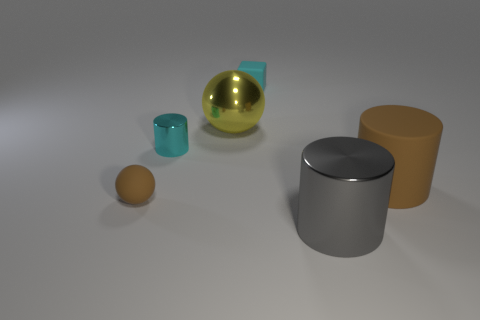Is there anything else that has the same material as the small cylinder?
Ensure brevity in your answer.  Yes. What is the shape of the object that is the same color as the matte block?
Offer a terse response. Cylinder. Are there fewer large brown matte objects that are left of the small cyan block than tiny cyan shiny cylinders that are left of the small cyan cylinder?
Make the answer very short. No. Is the size of the cyan cylinder the same as the ball that is behind the brown cylinder?
Give a very brief answer. No. How many green shiny cylinders have the same size as the cyan rubber block?
Your answer should be compact. 0. How many big things are either brown rubber things or blue metal blocks?
Ensure brevity in your answer.  1. Are there any small matte cubes?
Offer a very short reply. Yes. Are there more brown rubber cylinders that are on the right side of the big brown thing than small cyan things that are in front of the big yellow thing?
Ensure brevity in your answer.  No. What is the color of the tiny rubber object that is in front of the big thing that is to the left of the big gray cylinder?
Your answer should be compact. Brown. Is there a small thing that has the same color as the rubber sphere?
Provide a short and direct response. No. 